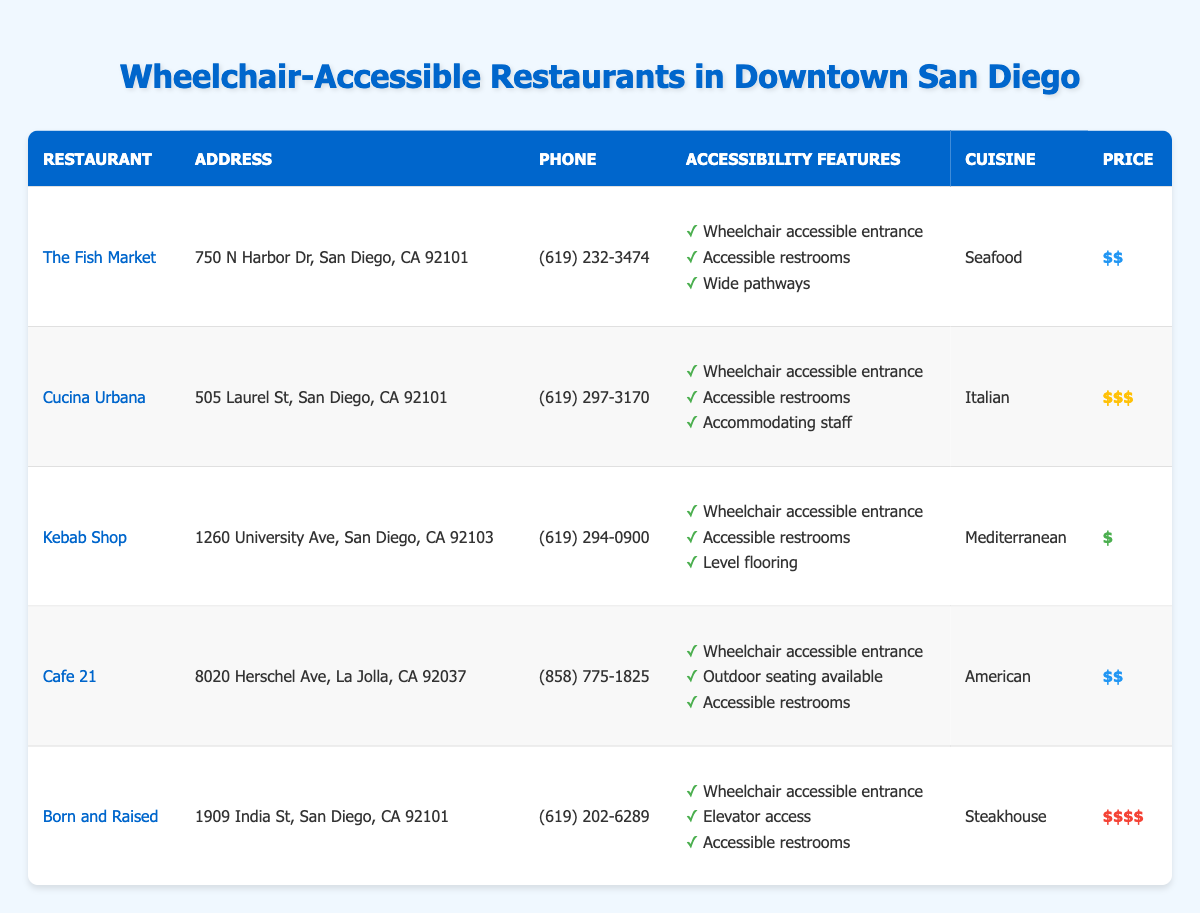What is the address of Cucina Urbana? The table lists Cucina Urbana with the address 505 Laurel St, San Diego, CA 92101.
Answer: 505 Laurel St, San Diego, CA 92101 Which restaurant has the highest average price? Upon reviewing the table, Born and Raised has an average price marked as $$$$, which is the highest among all listed restaurants.
Answer: Born and Raised Does Kebab Shop have accessible restrooms? By looking at Kebab Shop's entry in the table, it states that it offers accessible restrooms as part of its accessibility features.
Answer: Yes How many restaurants have a wheelchair-accessible entrance? The table shows that all five restaurants listed have a wheelchair-accessible entrance, providing a total count of 5.
Answer: 5 What is the average price of the restaurants that serve Italian cuisine? The only restaurant serving Italian cuisine is Cucina Urbana, with an average price of $$$. Thus, the average for Italian cuisine is the same as its price.
Answer: $$$ Which restaurant offers elevator access and what is its cuisine? The table indicates that Born and Raised features elevator access and provides steakhouse cuisine. The required information is gathered from the respective columns for that restaurant.
Answer: Born and Raised, Steakhouse Is there a restaurant on the list that serves American cuisine and has outdoor seating available? The entry for Cafe 21 in the table specifies that it serves American cuisine and mentions outdoor seating as an accessibility feature, confirming the statement.
Answer: Yes What are the accessibility features of The Fish Market? The table lists three accessibility features for The Fish Market: a wheelchair accessible entrance, accessible restrooms, and wide pathways. This information is directly found in the accessibility features section of the entry.
Answer: Wheelchair accessible entrance, Accessible restrooms, Wide pathways How many Mediterranean cuisine restaurants are there, and what are their names? The Kebab Shop is the only restaurant listed that serves Mediterranean cuisine, so the total number of Mediterranean restaurants is one, and its name is derived from its entry in the table.
Answer: 1, Kebab Shop 